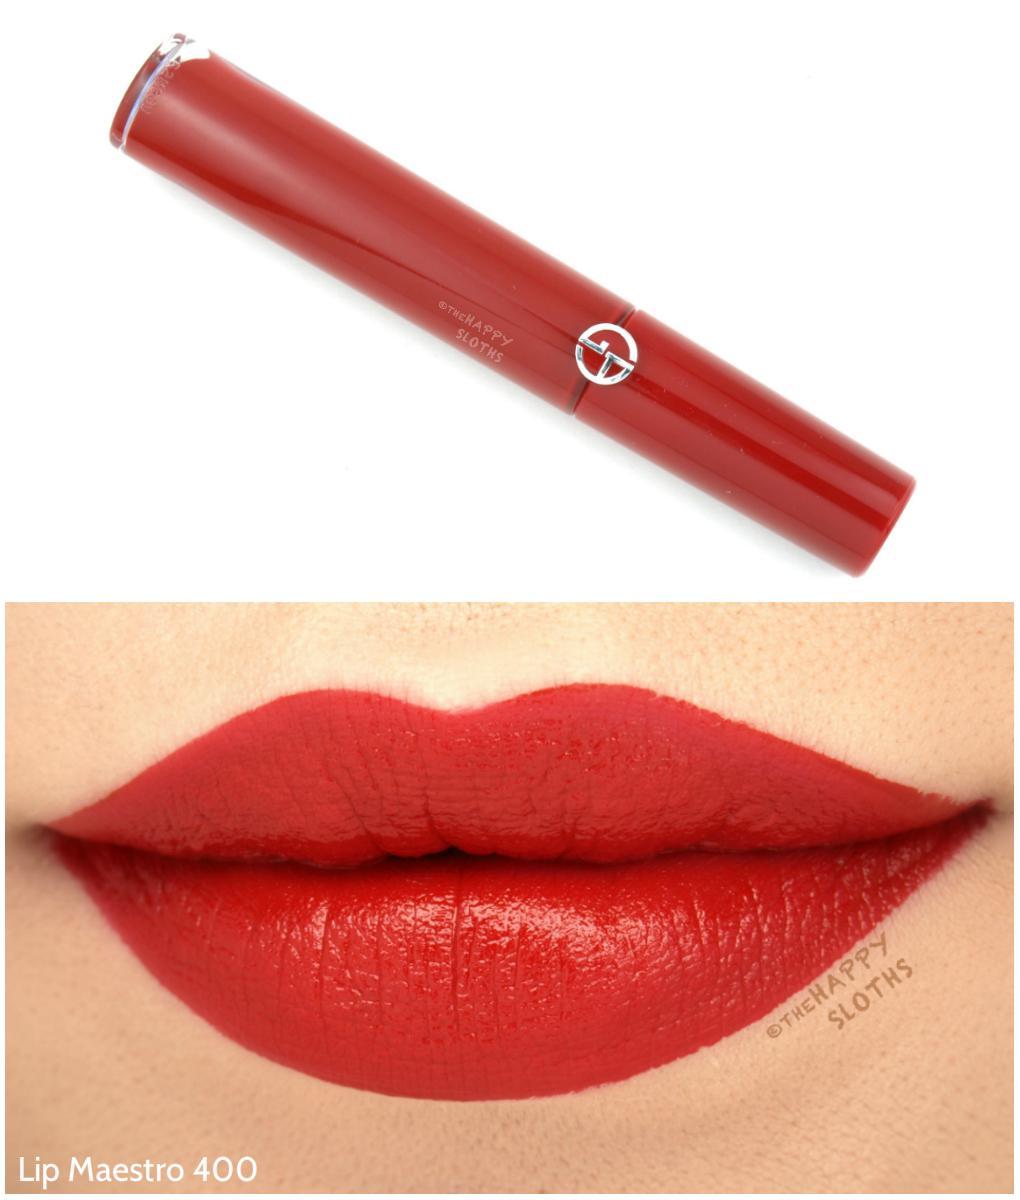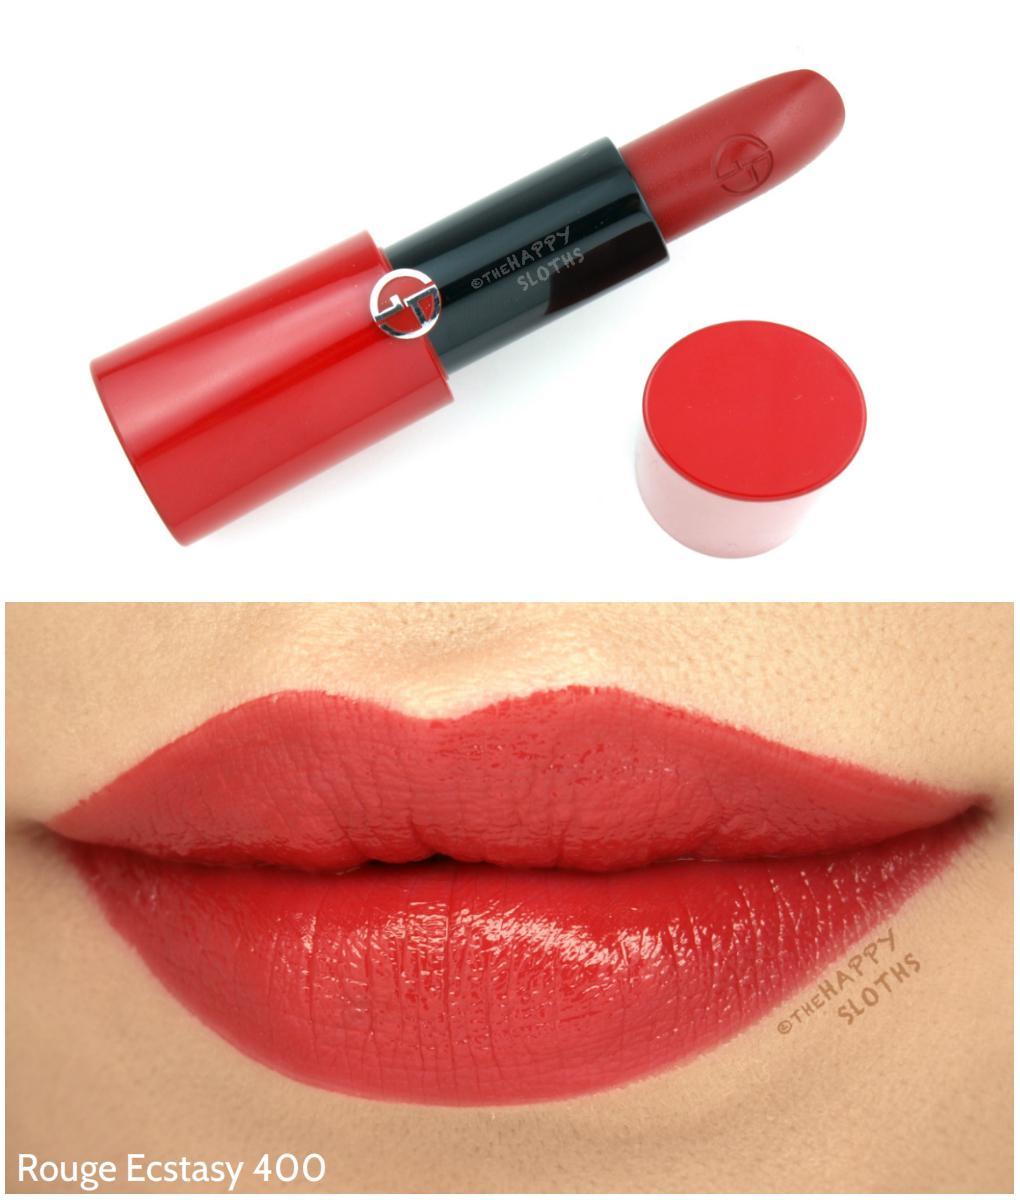The first image is the image on the left, the second image is the image on the right. For the images displayed, is the sentence "One image shows an unlidded tube lipstick next to a small pot with a solid-colored top, over a pair of tinted lips." factually correct? Answer yes or no. Yes. The first image is the image on the left, the second image is the image on the right. Analyze the images presented: Is the assertion "The lipstick on the left comes in a red case." valid? Answer yes or no. Yes. 